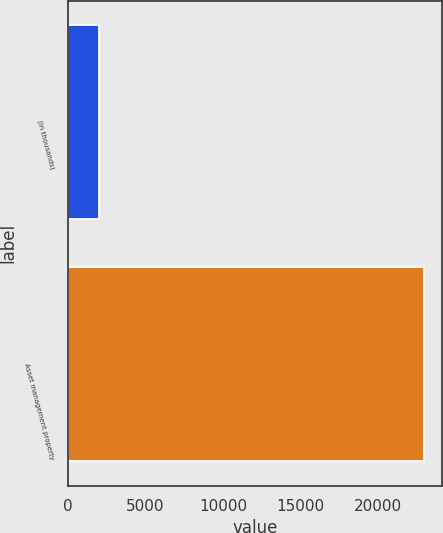Convert chart to OTSL. <chart><loc_0><loc_0><loc_500><loc_500><bar_chart><fcel>(in thousands)<fcel>Asset management property<nl><fcel>2014<fcel>22983<nl></chart> 